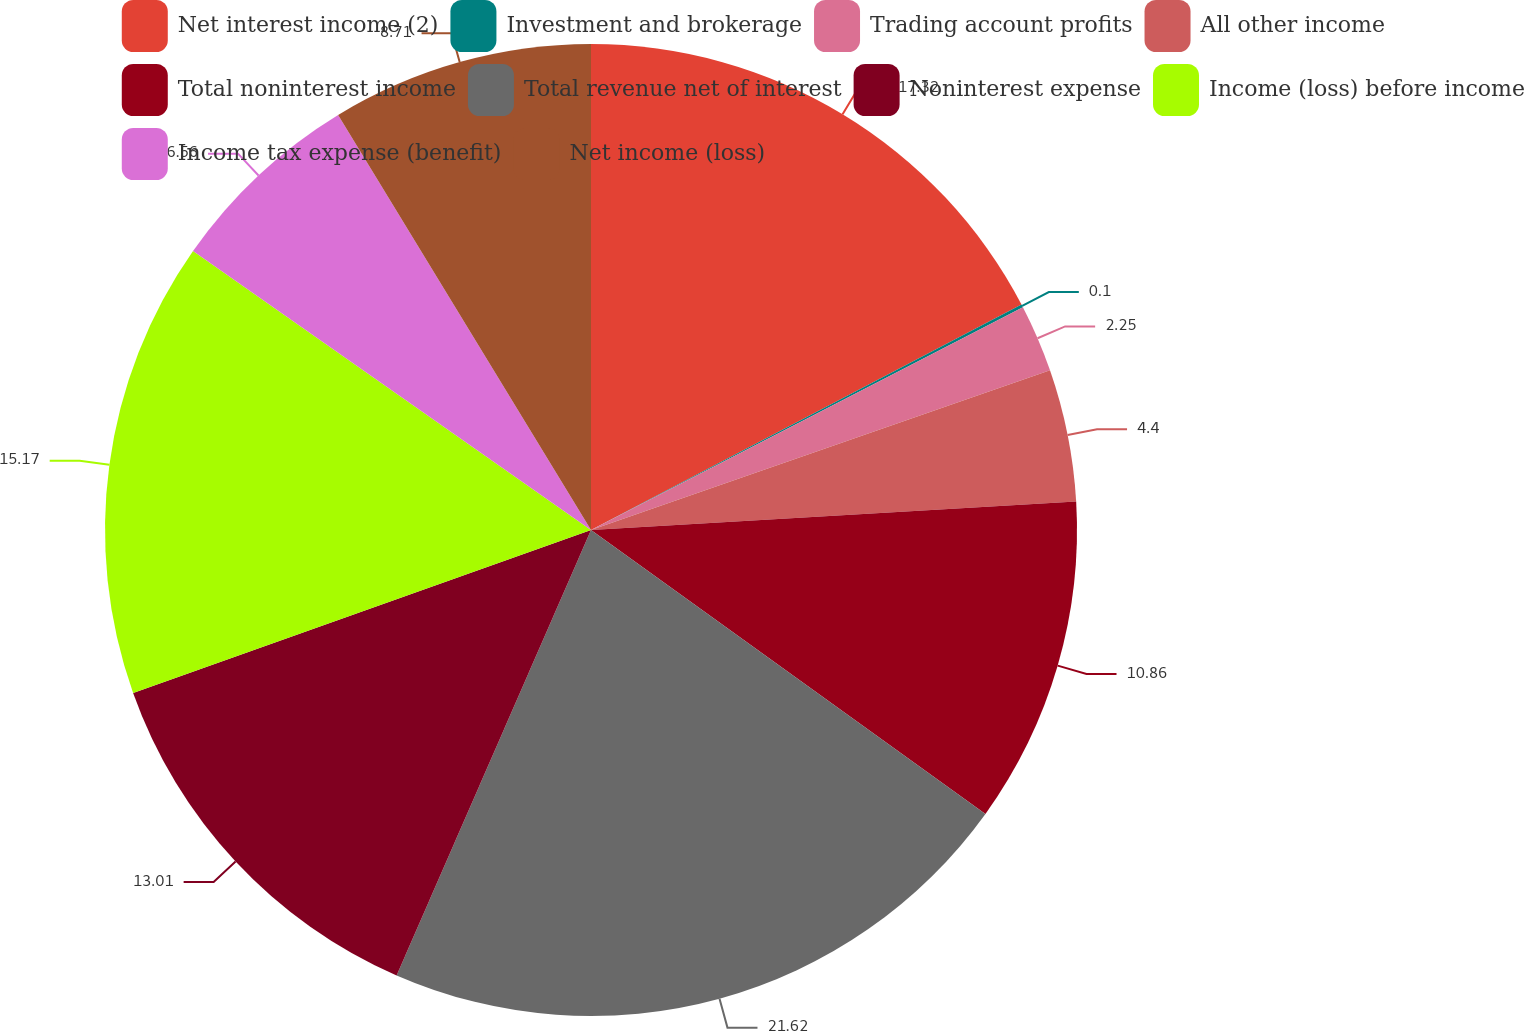<chart> <loc_0><loc_0><loc_500><loc_500><pie_chart><fcel>Net interest income (2)<fcel>Investment and brokerage<fcel>Trading account profits<fcel>All other income<fcel>Total noninterest income<fcel>Total revenue net of interest<fcel>Noninterest expense<fcel>Income (loss) before income<fcel>Income tax expense (benefit)<fcel>Net income (loss)<nl><fcel>17.32%<fcel>0.1%<fcel>2.25%<fcel>4.4%<fcel>10.86%<fcel>21.62%<fcel>13.01%<fcel>15.17%<fcel>6.56%<fcel>8.71%<nl></chart> 